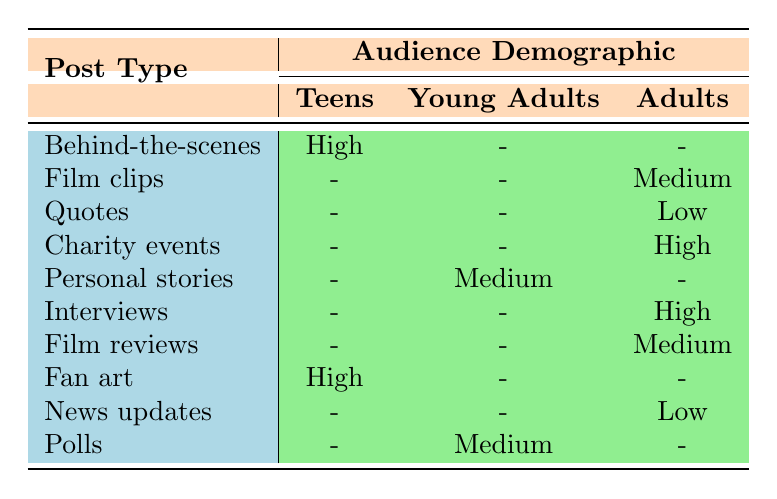What is the engagement level for "Behind-the-scenes" posts among Teens? According to the table, "Behind-the-scenes" posts have an engagement level listed as "High" for the Teens demographic.
Answer: High Which post type has the lowest engagement for the Adults demographic? Looking through the Adults column, the post type with the lowest engagement is "News updates," which shows a "Low" engagement level.
Answer: News updates How many post types have Medium engagement for Young Adults? From the table, only one post type, "Personal stories," has a Medium engagement listed under Young Adults.
Answer: One Is there any post type that engages Teens and has a High rating? The table shows that both "Behind-the-scenes" and "Fan art" post types have a High engagement rating for the Teens demographic.
Answer: Yes Which audience demographic engages the most with interviews? The table indicates that the "Interviews" post type engages the Adults 45-54 demographic at a High level.
Answer: Adults 45-54 What is the engagement level of "Film reviews" posts among Young Adults? The table shows that "Film reviews" have a Medium engagement level for Young Adults.
Answer: Medium Which post type has more High engagement rates: "Charity events" or "Interviews"? The table states that both "Charity events" and "Interviews" have a High engagement level but they target different demographics: "Charity events" engage Adults 35-44, while "Interviews" engage Adults 45-54. Hence, they have equal High engagement rates.
Answer: Equal High engagement rates Can you find a post type that appeals to both Teens and Young Adults? Upon reviewing the table, there are no post types that have engagements listed for both Teens and Young Adults. Each post type is targeted at one demographic or the other.
Answer: No 